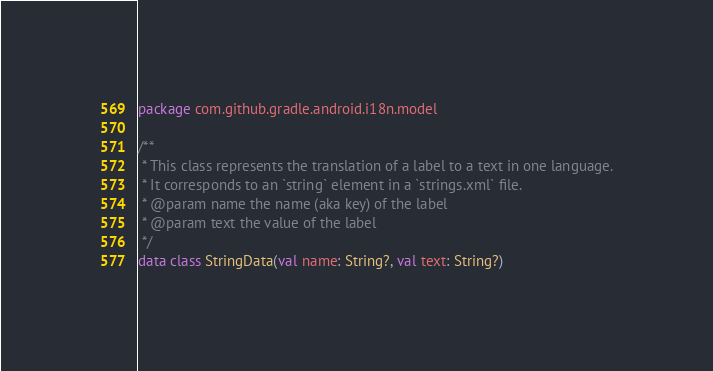Convert code to text. <code><loc_0><loc_0><loc_500><loc_500><_Kotlin_>package com.github.gradle.android.i18n.model

/**
 * This class represents the translation of a label to a text in one language.
 * It corresponds to an `string` element in a `strings.xml` file.
 * @param name the name (aka key) of the label
 * @param text the value of the label
 */
data class StringData(val name: String?, val text: String?)
</code> 